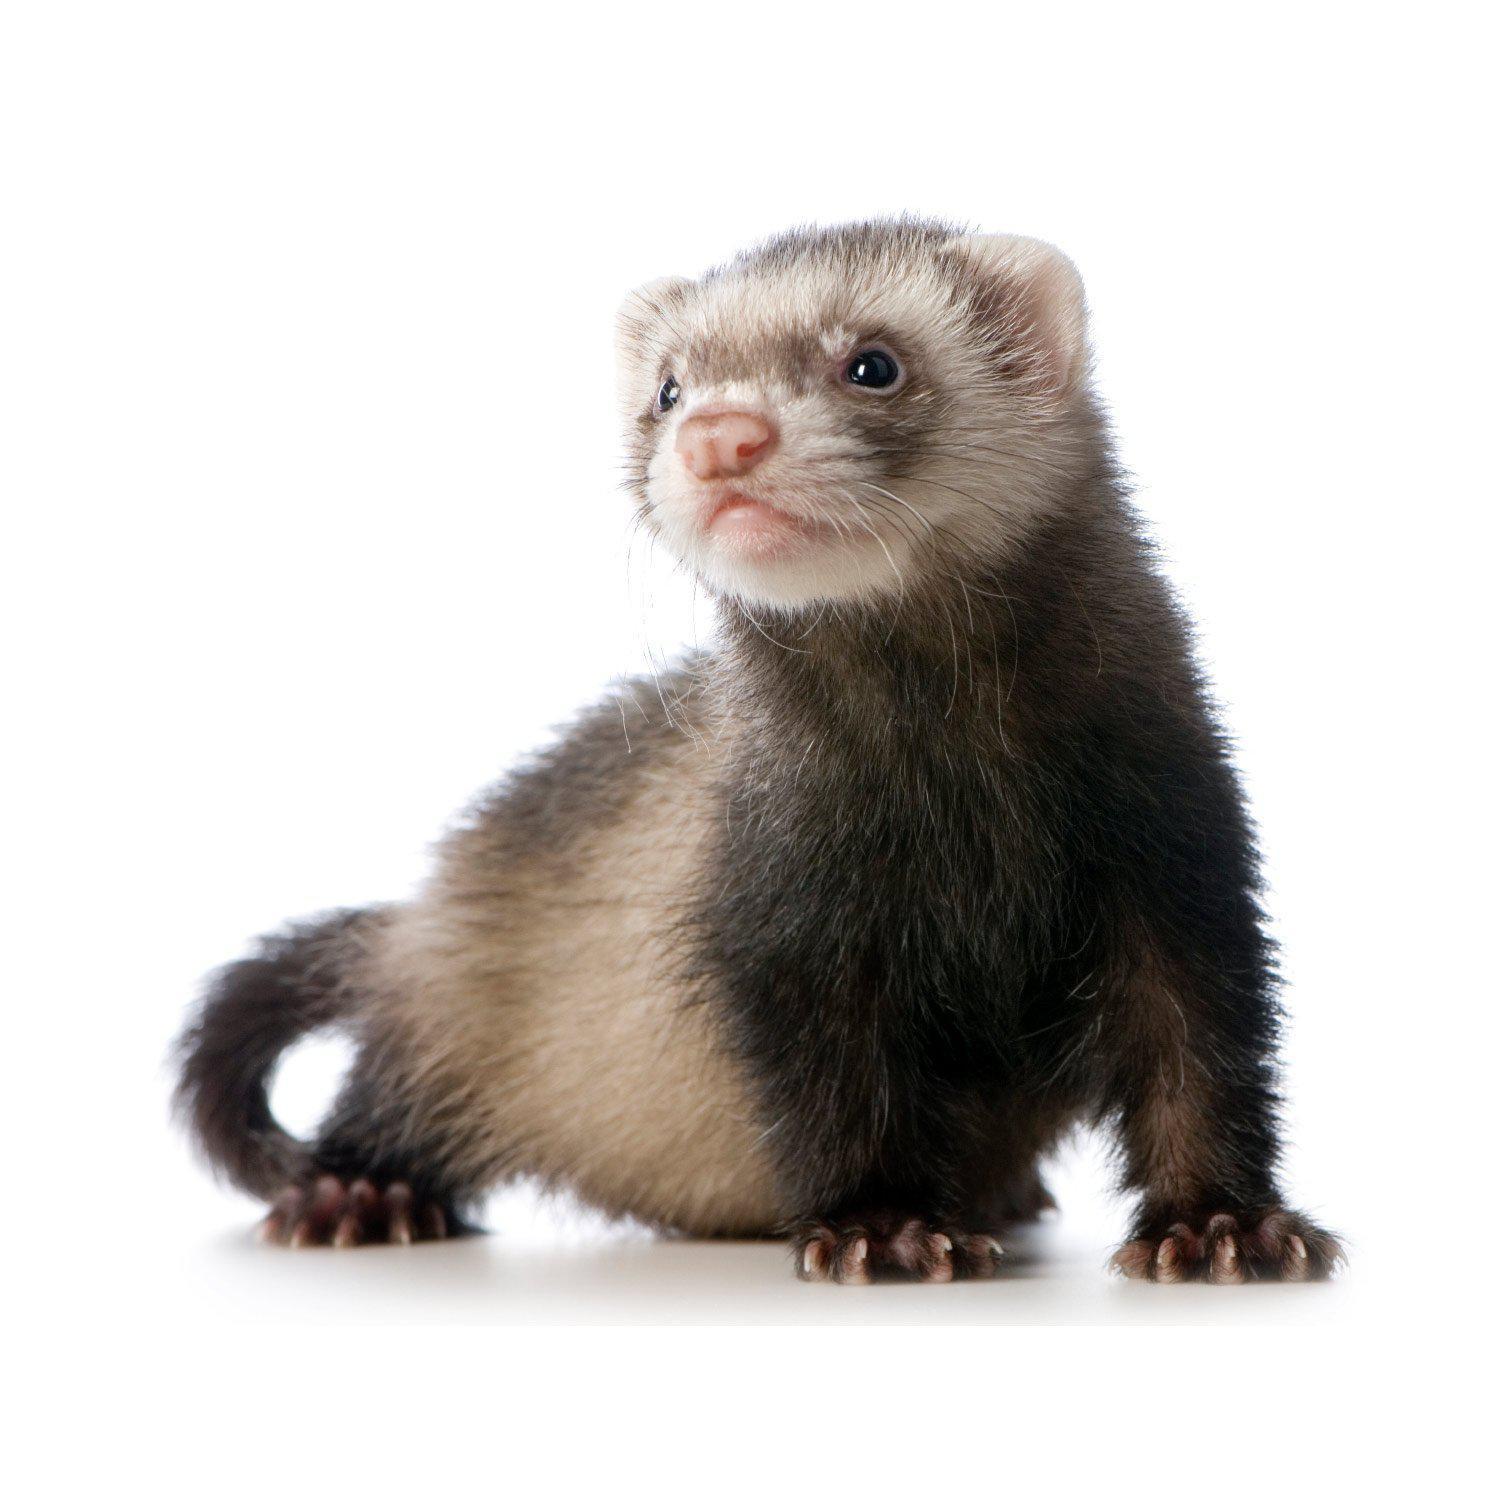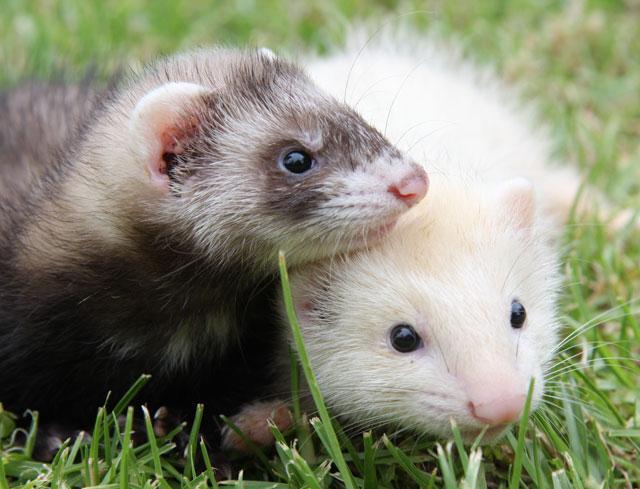The first image is the image on the left, the second image is the image on the right. Examine the images to the left and right. Is the description "The right image depicts more ferrets than the left image." accurate? Answer yes or no. Yes. 